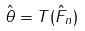Convert formula to latex. <formula><loc_0><loc_0><loc_500><loc_500>\hat { \theta } = T ( \hat { F } _ { n } )</formula> 